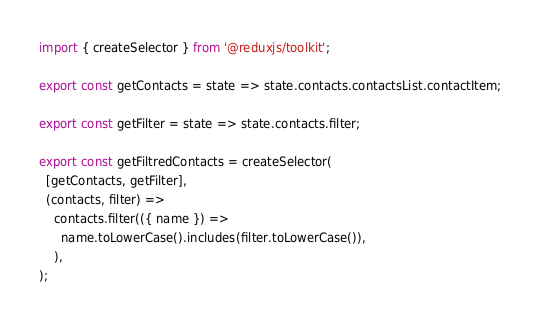<code> <loc_0><loc_0><loc_500><loc_500><_JavaScript_>import { createSelector } from '@reduxjs/toolkit';

export const getContacts = state => state.contacts.contactsList.contactItem;

export const getFilter = state => state.contacts.filter;

export const getFiltredContacts = createSelector(
  [getContacts, getFilter],
  (contacts, filter) =>
    contacts.filter(({ name }) =>
      name.toLowerCase().includes(filter.toLowerCase()),
    ),
);
</code> 